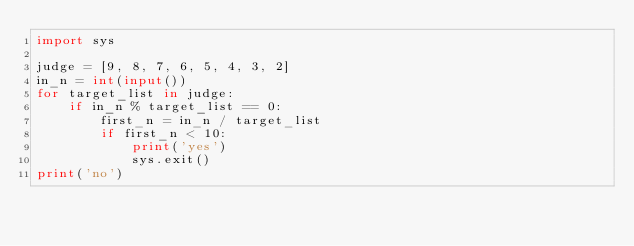<code> <loc_0><loc_0><loc_500><loc_500><_Python_>import sys

judge = [9, 8, 7, 6, 5, 4, 3, 2]
in_n = int(input())
for target_list in judge:
    if in_n % target_list == 0:
        first_n = in_n / target_list
        if first_n < 10:
            print('yes')
            sys.exit()
print('no')
</code> 